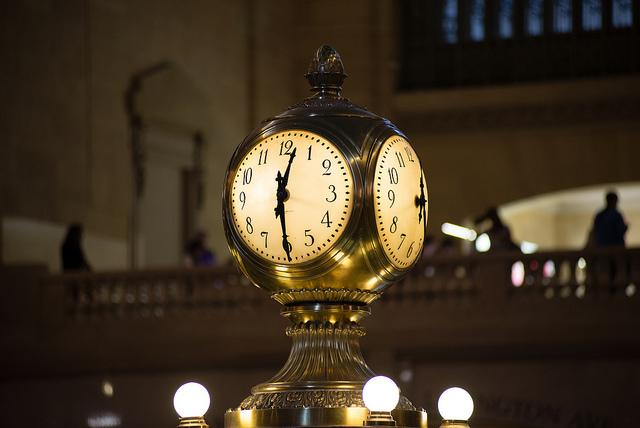If the clock is showing times in the PM how many hours ago did the New York Stock Exchange open? Please explain your reasoning. three. The nyse opens at 9:30 am and the clock displays 12:30 pm. 